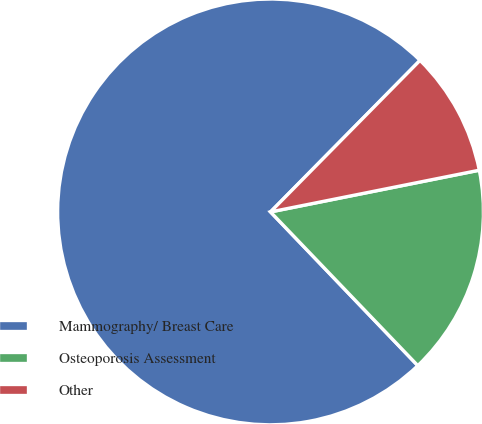Convert chart to OTSL. <chart><loc_0><loc_0><loc_500><loc_500><pie_chart><fcel>Mammography/ Breast Care<fcel>Osteoporosis Assessment<fcel>Other<nl><fcel>74.56%<fcel>15.98%<fcel>9.47%<nl></chart> 